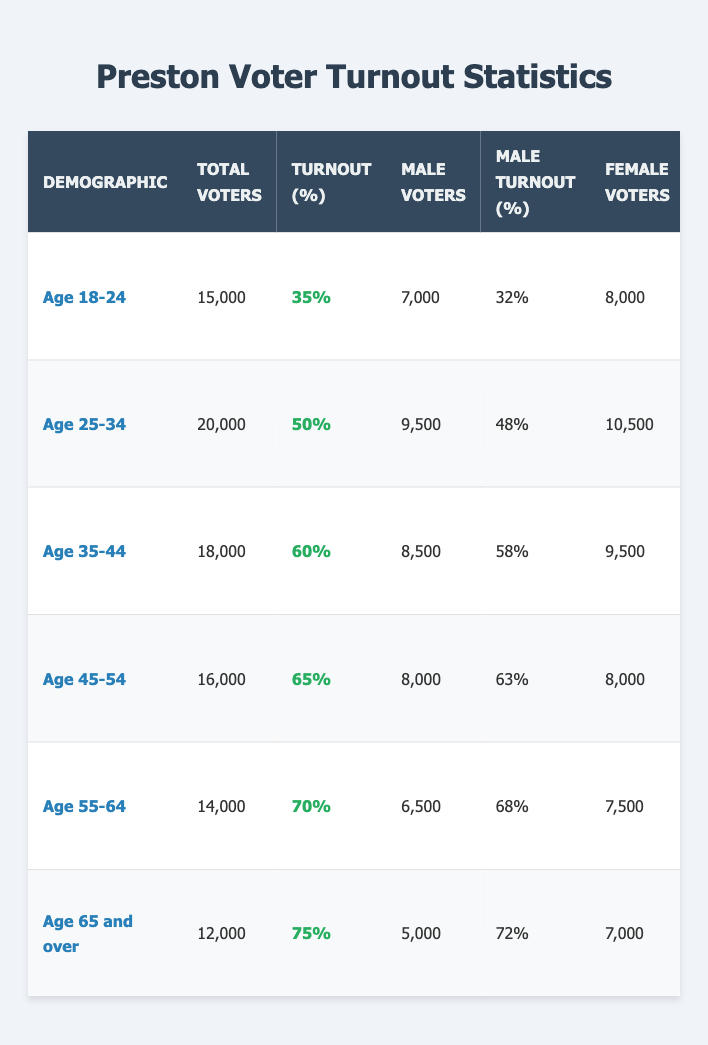What is the voter turnout percentage for the age group 18-24? The table shows that the turnout for the age group 18-24 is listed under the 'Turnout (%)' column for that demographic, which is 35%.
Answer: 35% Which age group had the highest total number of voters? By comparing the 'Total Voters' column across all age groups, it is clear that the age group 25-34, with 20,000 voters, has the highest total number of voters.
Answer: Age 25-34 What is the difference in turnout percentage between the age groups 45-54 and 55-64? The turnout for age group 45-54 is 65%, while for 55-64 it is 70%. The difference is calculated as 70 - 65 = 5%.
Answer: 5% How many male voters were there in the age group 65 and over? Looking at the 'Male Voters' column for the demographic 'Age 65 and over', the table indicates there were 5,000 male voters.
Answer: 5,000 What percentage of the total voters in the age 35-44 group were Black? The total voters in the age 35-44 group are 18,000. The percentage of Black voters is 5%, which is calculated as (5/100) * 18,000 = 900.
Answer: 900 Which gender had a higher turnout in the age group 45-54? The 'Male Turnout (%)' for this demographic is 63% and the 'Female Turnout (%)' is 67%. Since 67% is greater than 63%, females had a higher turnout.
Answer: Females What is the average voter turnout percentage across all age groups? To find the average, sum the turnout percentages for all age groups (35 + 50 + 60 + 65 + 70 + 75) = 355 and divide by the number of age groups, which is 6. Therefore, 355 / 6 = approximately 59.17%.
Answer: Approximately 59.17% Is the turnout percentage for males in the age group 55-64 higher than that for females in the age group 25-34? The 'Male Turnout (%)' for the age group 55-64 is 68%, and the 'Female Turnout (%)' for the age group 25-34 is 52%. Since 68% is greater than 52%, the statement is true.
Answer: Yes What is the total number of voters for all age groups combined? By summing the 'Total Voters' across all age groups: 15,000 + 20,000 + 18,000 + 16,000 + 14,000 + 12,000 = 95,000.
Answer: 95,000 Are there more male voters in the age group 18-24 than in the age group 25-34? The number of male voters for age group 18-24 is 7,000 while for age group 25-34 it is 9,500. Since 7,000 is less than 9,500, the statement is false.
Answer: No 